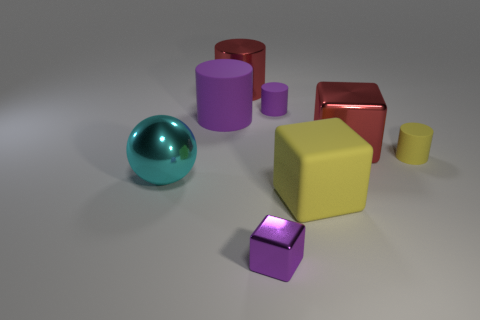Does the large shiny block have the same color as the metallic cylinder?
Ensure brevity in your answer.  Yes. There is a yellow object that is the same shape as the tiny purple shiny object; what material is it?
Make the answer very short. Rubber. The red shiny thing that is left of the red metallic thing in front of the small purple thing that is behind the yellow matte cylinder is what shape?
Your answer should be very brief. Cylinder. What is the material of the small cylinder that is the same color as the large matte block?
Your response must be concise. Rubber. How many purple matte objects are the same shape as the large yellow thing?
Ensure brevity in your answer.  0. There is a shiny thing left of the big metal cylinder; does it have the same color as the large matte object to the right of the small cube?
Provide a short and direct response. No. What is the material of the purple cylinder that is the same size as the yellow rubber block?
Your answer should be very brief. Rubber. Are there any metallic things of the same size as the purple shiny block?
Make the answer very short. No. Are there fewer red metallic things on the right side of the big yellow rubber block than small green rubber balls?
Ensure brevity in your answer.  No. Is the number of tiny matte cylinders behind the red block less than the number of tiny purple blocks behind the purple metal thing?
Provide a succinct answer. No. 